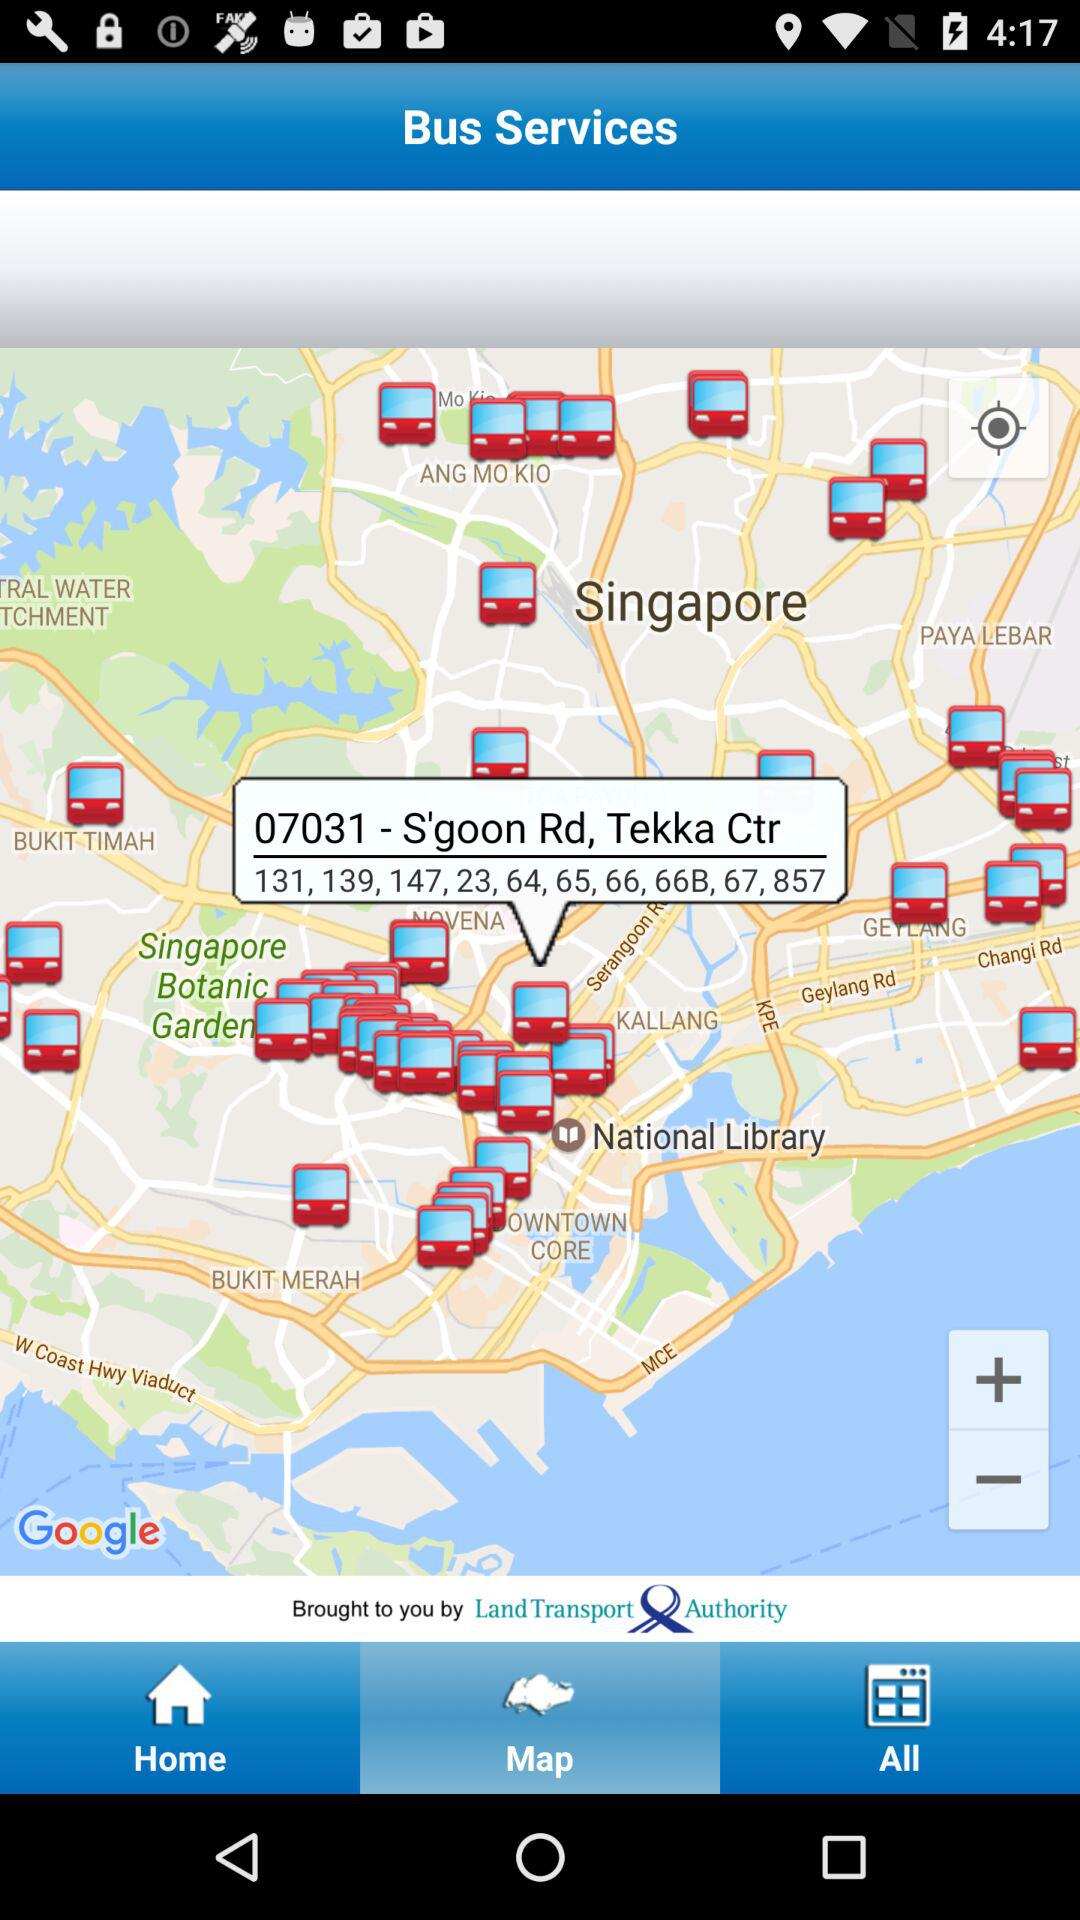Which tab is selected? The selected tab is map. 